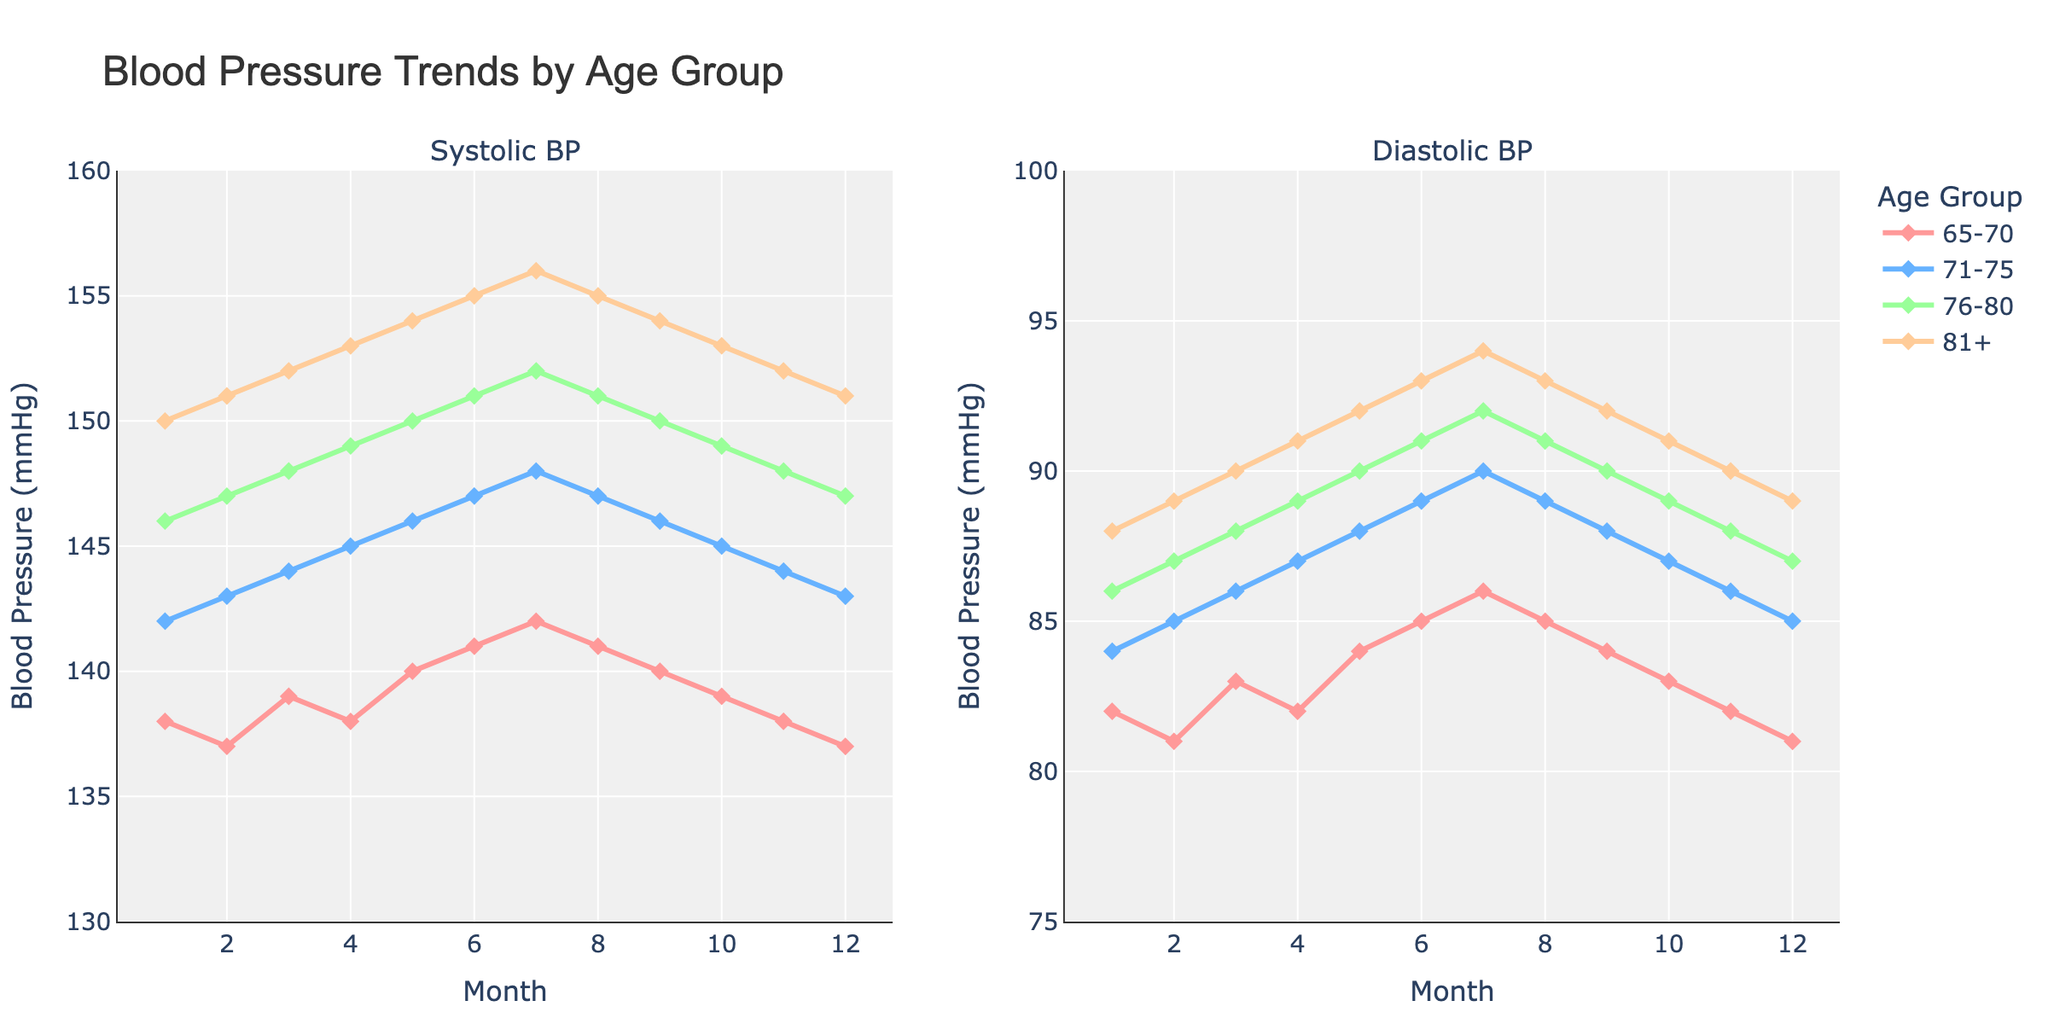Which age group has the highest systolic blood pressure in month 6? To find the highest systolic blood pressure in month 6, look at the plot for the systolic BP in month 6 for each age group. Compare the values: 65-70 (141), 71-75 (147), 76-80 (151), 81+ (155). The highest is 155 for the age group 81+.
Answer: 81+ What is the difference in diastolic blood pressure between the age groups 65-70 and 81+ in month 3? To find the difference, look at the diastolic BP for both age groups in month 3. The values are 65-70 (83) and 81+ (90). Subtract 83 from 90 to get the difference.
Answer: 7 Which age group has the steadiest systolic blood pressure trend over the 12 months? To identify the steadiest trend, look for the line with the least fluctuation in the systolic BP plot. The age group 65-70 shows the most consistent trend with values ranging from 137 to 142.
Answer: 65-70 In which month does the systolic blood pressure for the age group 76-80 peak? Look at the systolic BP plot for the age group 76-80 and find the highest point. The peak occurs in month 7 with a value of 152.
Answer: 7 What is the average diastolic blood pressure for the age group 71-75 across the 12 months? Add up all the diastolic BP values for the age group 71-75 and divide by 12. The values are 84, 85, 86, 87, 88, 89, 90, 89, 88, 87, 86, 85. The sum is 1034. Divide 1034 by 12 to get the average.
Answer: 86.17 How does the systolic blood pressure trend for the age group 81+ compare with the age group 65-70? Check the overall direction and changes in the line chart for both age groups' systolic BP trends. The age group 81+ shows a consistent increase up to month 7 and then a consistent decrease. The age group 65-70 has smaller fluctuations with less overall change.
Answer: 81+ shows more fluctuation Which month shows the largest gap in systolic blood pressure between the age groups 65-70 and 71-75? Calculate the difference in systolic BP for each month for the age groups 65-70 and 71-75. Identify the month with the largest gap. For instance, month 7 has 142 (65-70) vs. 148 (71-75), a difference of 6. Check other months to confirm it's the largest gap.
Answer: 7 